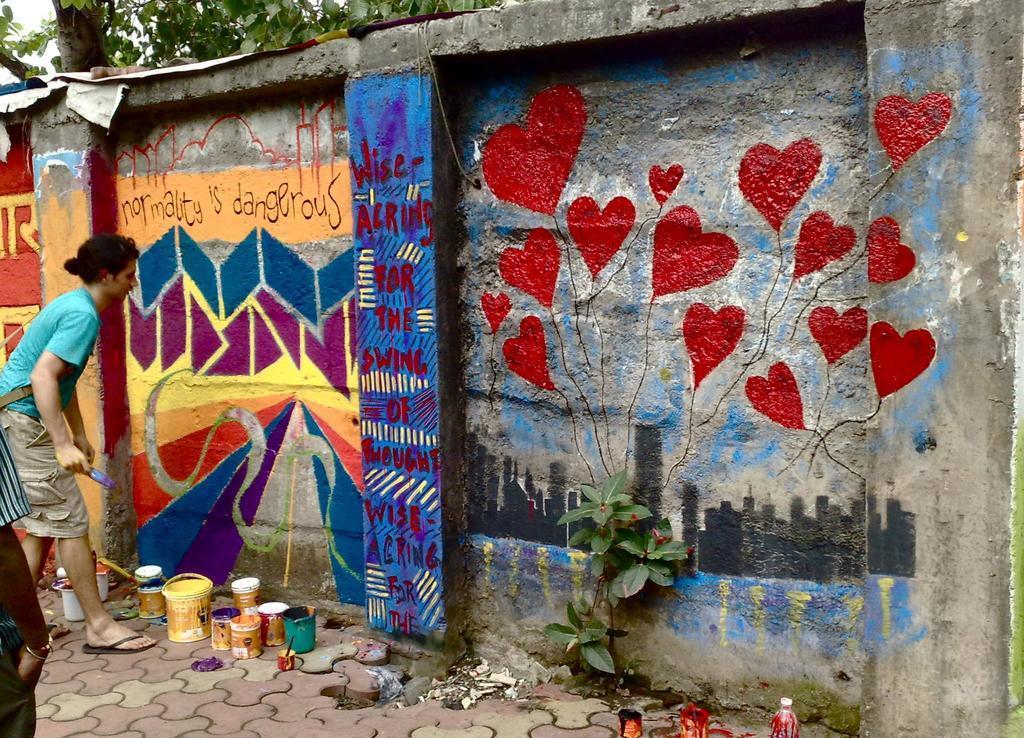Can you describe this image briefly? In this picture we can see some text and painting on the wall. There are a few buckets, bottles and other objects visible on the path. We can see a plant on a path. There is a person holding a rush in his hand. We can see another person on the left side. It looks like there are a few plants visible in the background. 